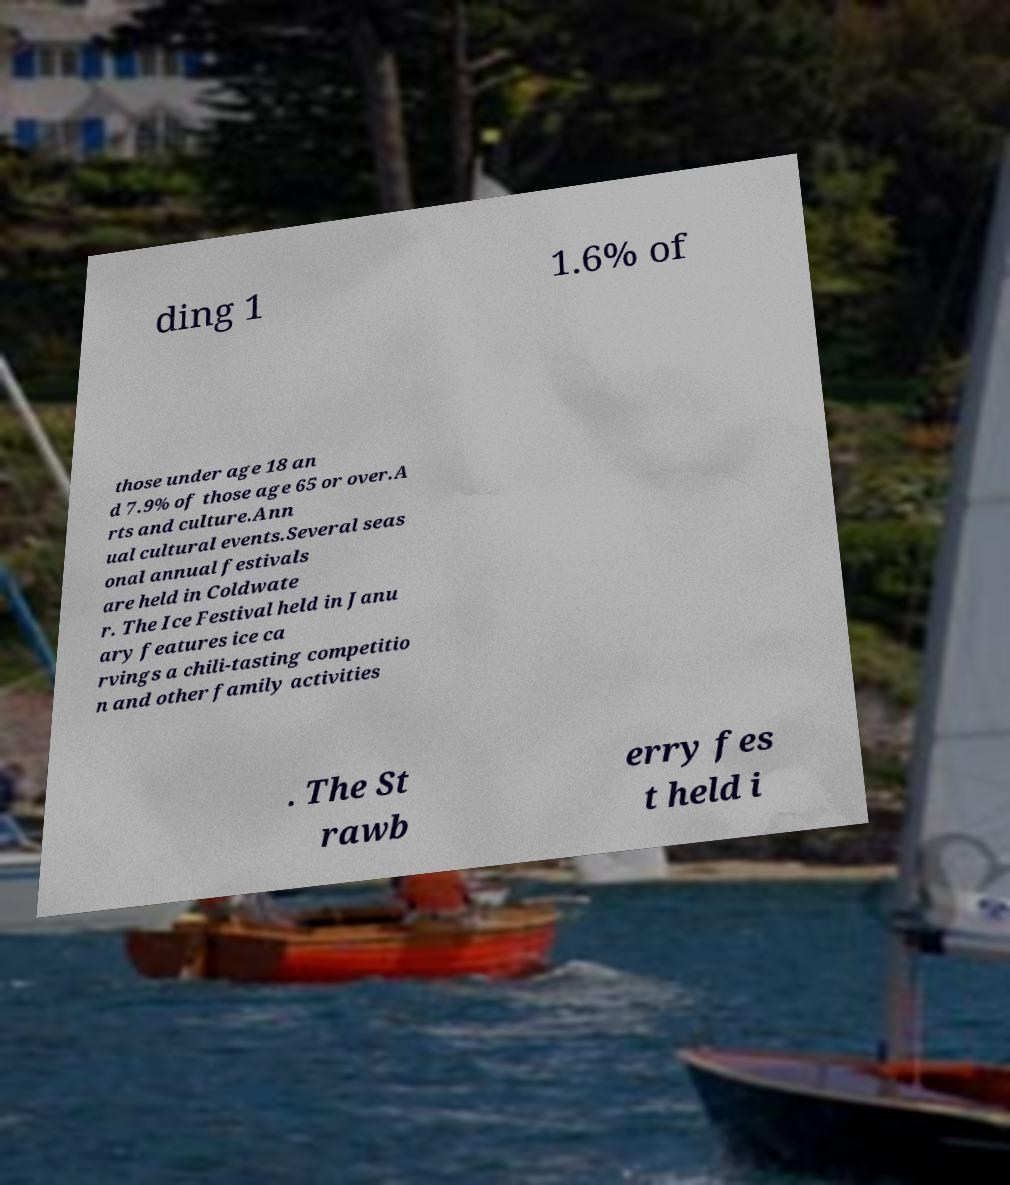Please read and relay the text visible in this image. What does it say? ding 1 1.6% of those under age 18 an d 7.9% of those age 65 or over.A rts and culture.Ann ual cultural events.Several seas onal annual festivals are held in Coldwate r. The Ice Festival held in Janu ary features ice ca rvings a chili-tasting competitio n and other family activities . The St rawb erry fes t held i 